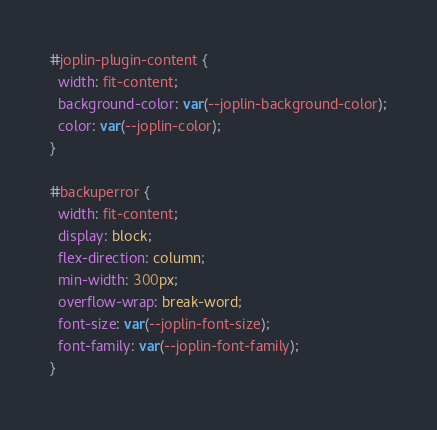<code> <loc_0><loc_0><loc_500><loc_500><_CSS_>#joplin-plugin-content {
  width: fit-content;
  background-color: var(--joplin-background-color);
  color: var(--joplin-color);
}

#backuperror {
  width: fit-content;
  display: block;
  flex-direction: column;
  min-width: 300px;
  overflow-wrap: break-word;
  font-size: var(--joplin-font-size);
  font-family: var(--joplin-font-family);
}
</code> 